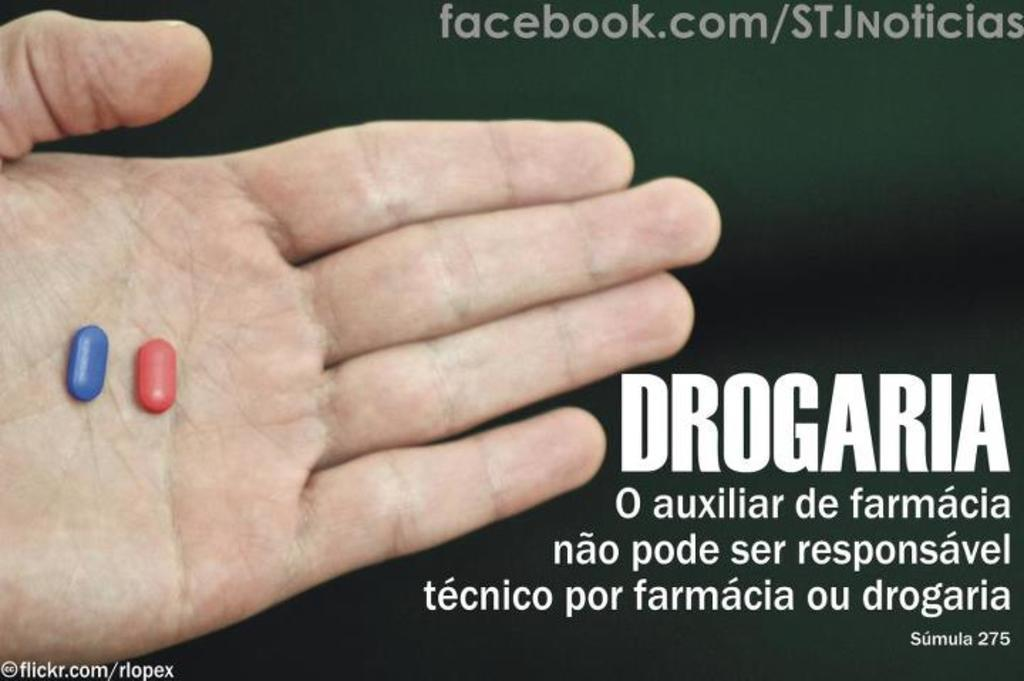What is present on the left side of the image? There is a hand with pills on the left side of the image. What can be seen in the image besides the hand with pills? There is a poster in the image. What is written or depicted on the poster? There is text on the poster. What type of quartz is being used to protest in the image? There is no quartz or protest present in the image; it features a hand with pills and a poster with text. How many slices of pie are visible in the image? There are no pies present in the image. 